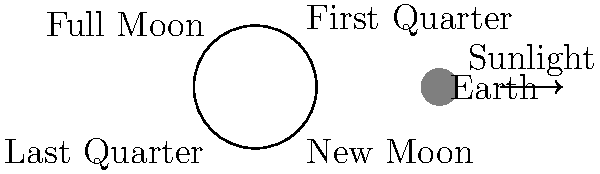Our beloved mascot is planning a special moon-themed halftime show. Can you help by explaining which phase of the moon we would see if it appears as a perfect half-circle in the sky, with the right half illuminated? Let's break this down step-by-step:

1. The moon's phases are caused by the changing angles between the Earth, moon, and Sun.

2. The illuminated portion of the moon we see from Earth depends on how much of the moon's sunlit side is facing us.

3. In the diagram, we can see four main phases of the moon:
   - New Moon: The dark side of the moon faces Earth
   - First Quarter: The right half of the moon is illuminated
   - Full Moon: The entire face of the moon is illuminated
   - Last Quarter: The left half of the moon is illuminated

4. When we see exactly half of the moon illuminated, it's either in the First Quarter or Last Quarter phase.

5. The question specifies that the right half is illuminated, which corresponds to the First Quarter phase.

6. During the First Quarter, the moon has completed 1/4 of its orbit around the Earth since the New Moon.

7. This phase occurs about 7 days after the New Moon and 7 days before the Full Moon.
Answer: First Quarter 